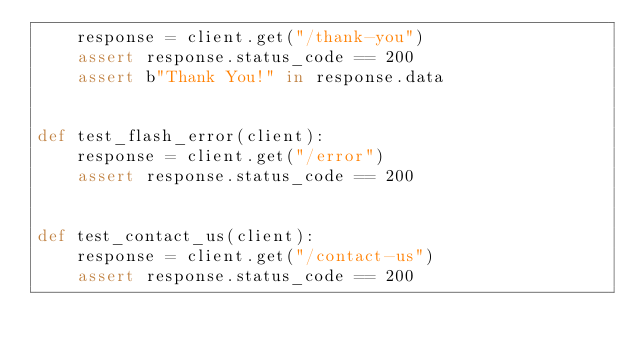<code> <loc_0><loc_0><loc_500><loc_500><_Python_>    response = client.get("/thank-you")
    assert response.status_code == 200
    assert b"Thank You!" in response.data
    
    
def test_flash_error(client):
    response = client.get("/error")
    assert response.status_code == 200
    

def test_contact_us(client):
    response = client.get("/contact-us")
    assert response.status_code == 200</code> 